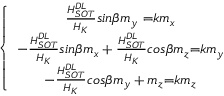<formula> <loc_0><loc_0><loc_500><loc_500>\left \{ \begin{array} { c } { \frac { H _ { S O T } ^ { D L } } { H _ { K } } { { \sin } \beta m _ { y } \ } { = } k m _ { x } } \\ { - \frac { H _ { S O T } ^ { D L } } { H _ { K } } { \sin } \beta m _ { x } + \frac { H _ { S O T } ^ { D L } } { H _ { K } } { \cos } \beta m _ { z } { = } k m _ { y } } \\ { - \frac { H _ { S O T } ^ { D L } } { H _ { K } } { \cos } \beta m _ { y } + m _ { z } { = } k m _ { z } } \end{array}</formula> 